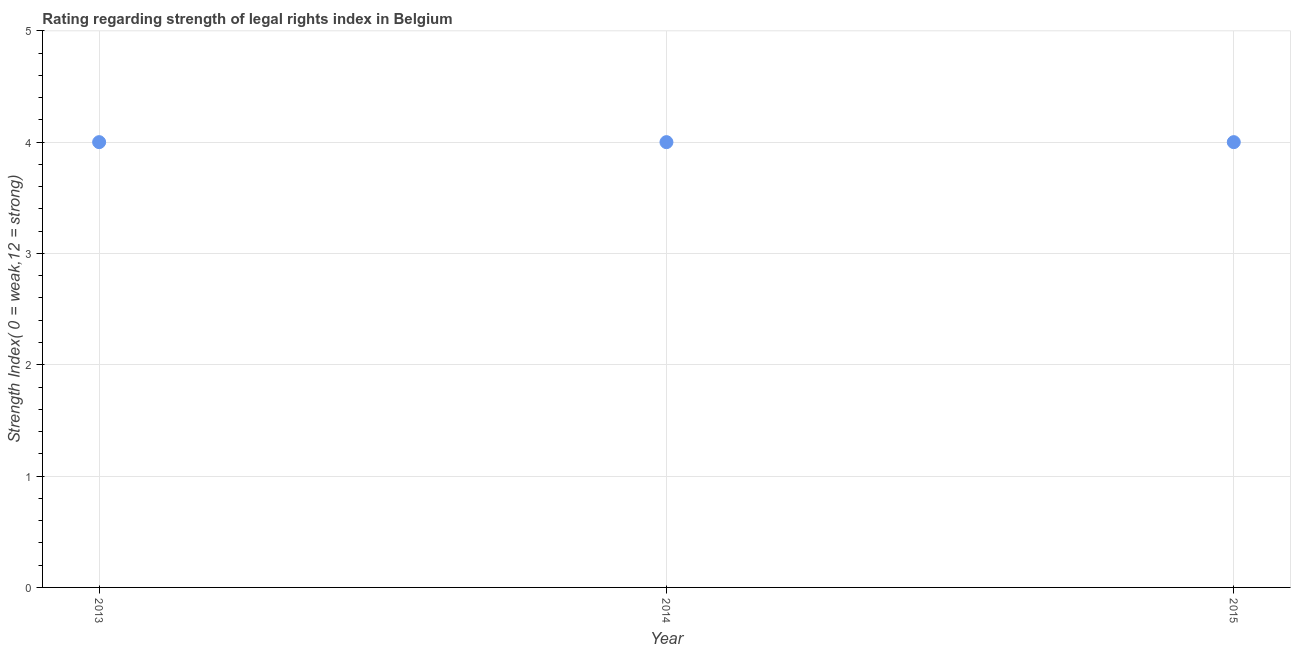What is the strength of legal rights index in 2013?
Make the answer very short. 4. Across all years, what is the maximum strength of legal rights index?
Keep it short and to the point. 4. Across all years, what is the minimum strength of legal rights index?
Ensure brevity in your answer.  4. What is the sum of the strength of legal rights index?
Your answer should be very brief. 12. In how many years, is the strength of legal rights index greater than 1.2 ?
Your response must be concise. 3. Do a majority of the years between 2015 and 2013 (inclusive) have strength of legal rights index greater than 4.6 ?
Make the answer very short. No. Is the sum of the strength of legal rights index in 2013 and 2014 greater than the maximum strength of legal rights index across all years?
Give a very brief answer. Yes. What is the difference between the highest and the lowest strength of legal rights index?
Offer a terse response. 0. What is the difference between two consecutive major ticks on the Y-axis?
Your response must be concise. 1. What is the title of the graph?
Your response must be concise. Rating regarding strength of legal rights index in Belgium. What is the label or title of the Y-axis?
Your answer should be compact. Strength Index( 0 = weak,12 = strong). What is the Strength Index( 0 = weak,12 = strong) in 2013?
Your response must be concise. 4. What is the Strength Index( 0 = weak,12 = strong) in 2014?
Offer a terse response. 4. What is the difference between the Strength Index( 0 = weak,12 = strong) in 2014 and 2015?
Your response must be concise. 0. What is the ratio of the Strength Index( 0 = weak,12 = strong) in 2013 to that in 2015?
Keep it short and to the point. 1. What is the ratio of the Strength Index( 0 = weak,12 = strong) in 2014 to that in 2015?
Provide a succinct answer. 1. 